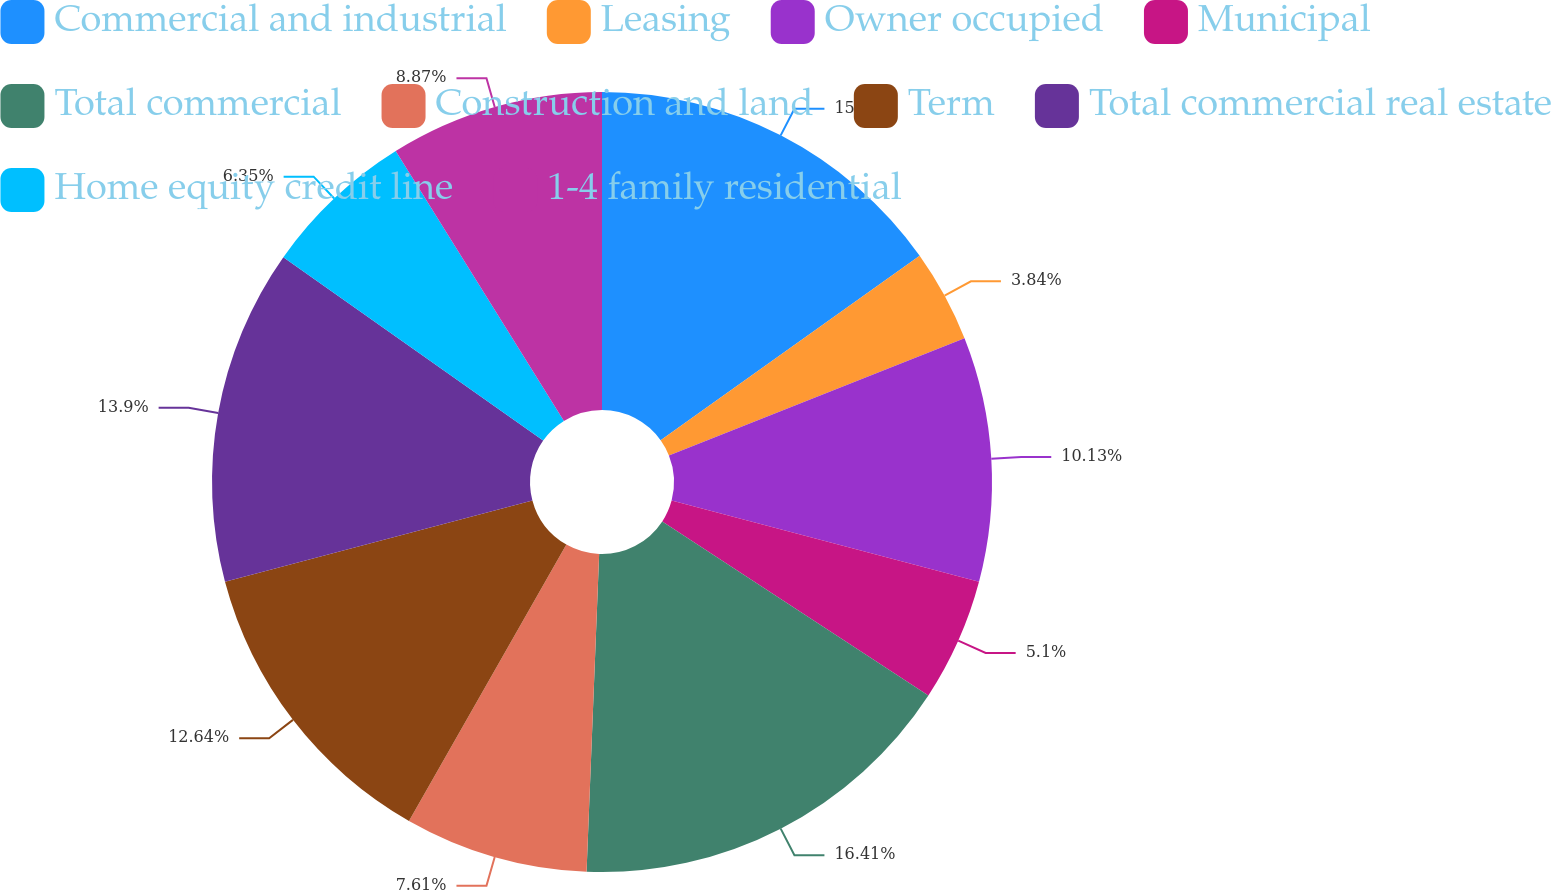<chart> <loc_0><loc_0><loc_500><loc_500><pie_chart><fcel>Commercial and industrial<fcel>Leasing<fcel>Owner occupied<fcel>Municipal<fcel>Total commercial<fcel>Construction and land<fcel>Term<fcel>Total commercial real estate<fcel>Home equity credit line<fcel>1-4 family residential<nl><fcel>15.15%<fcel>3.84%<fcel>10.13%<fcel>5.1%<fcel>16.41%<fcel>7.61%<fcel>12.64%<fcel>13.9%<fcel>6.35%<fcel>8.87%<nl></chart> 